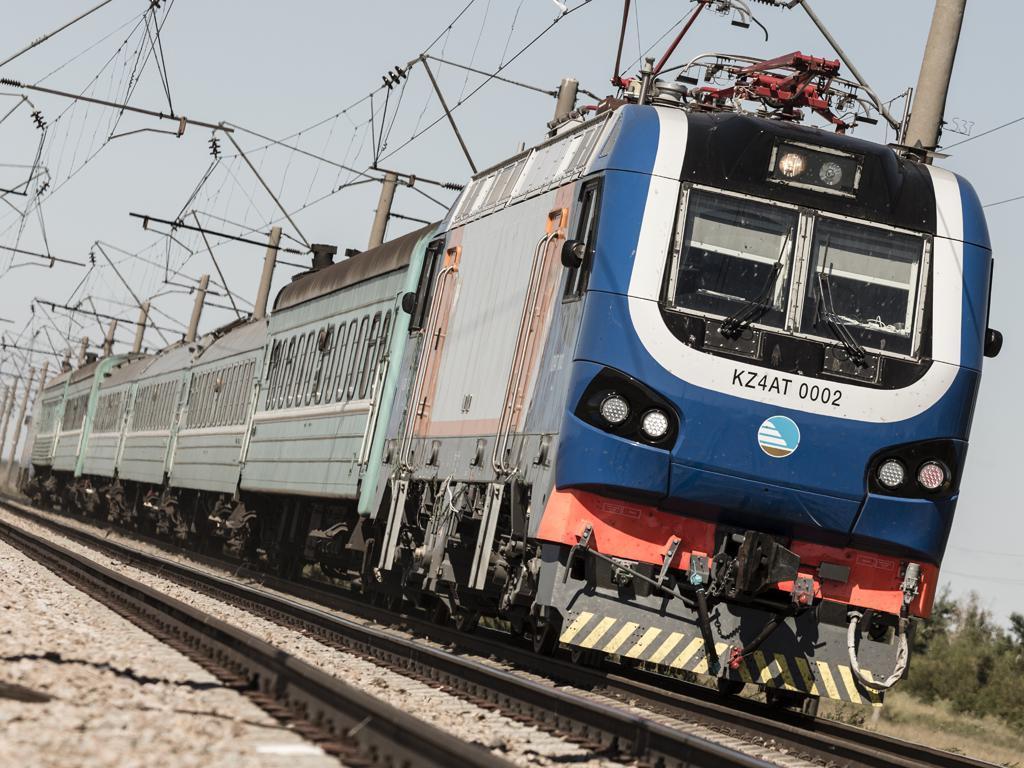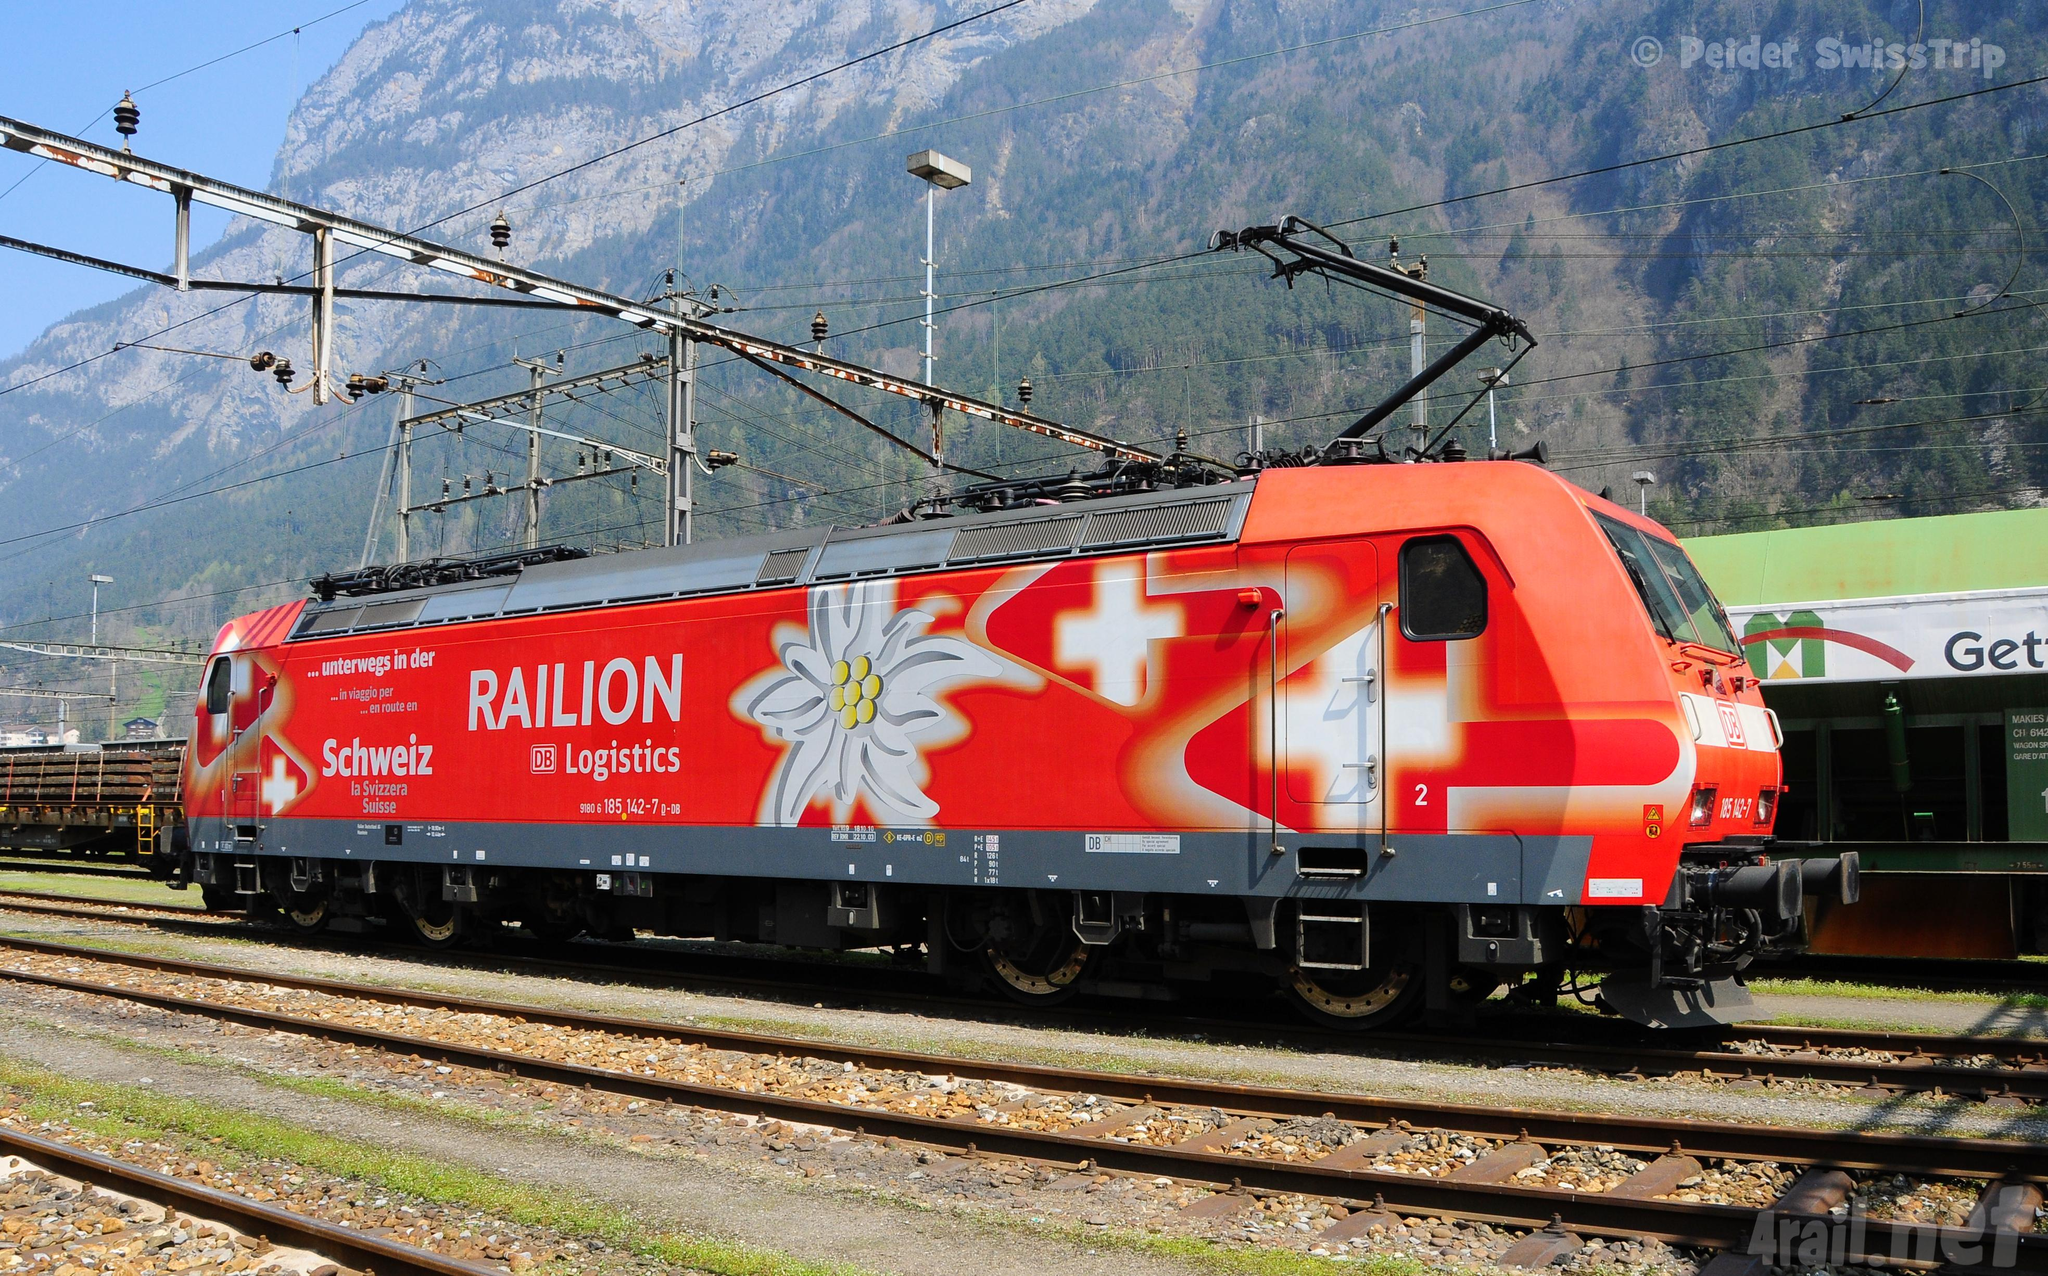The first image is the image on the left, the second image is the image on the right. For the images shown, is this caption "The train engine in one of the images is bright red." true? Answer yes or no. Yes. 